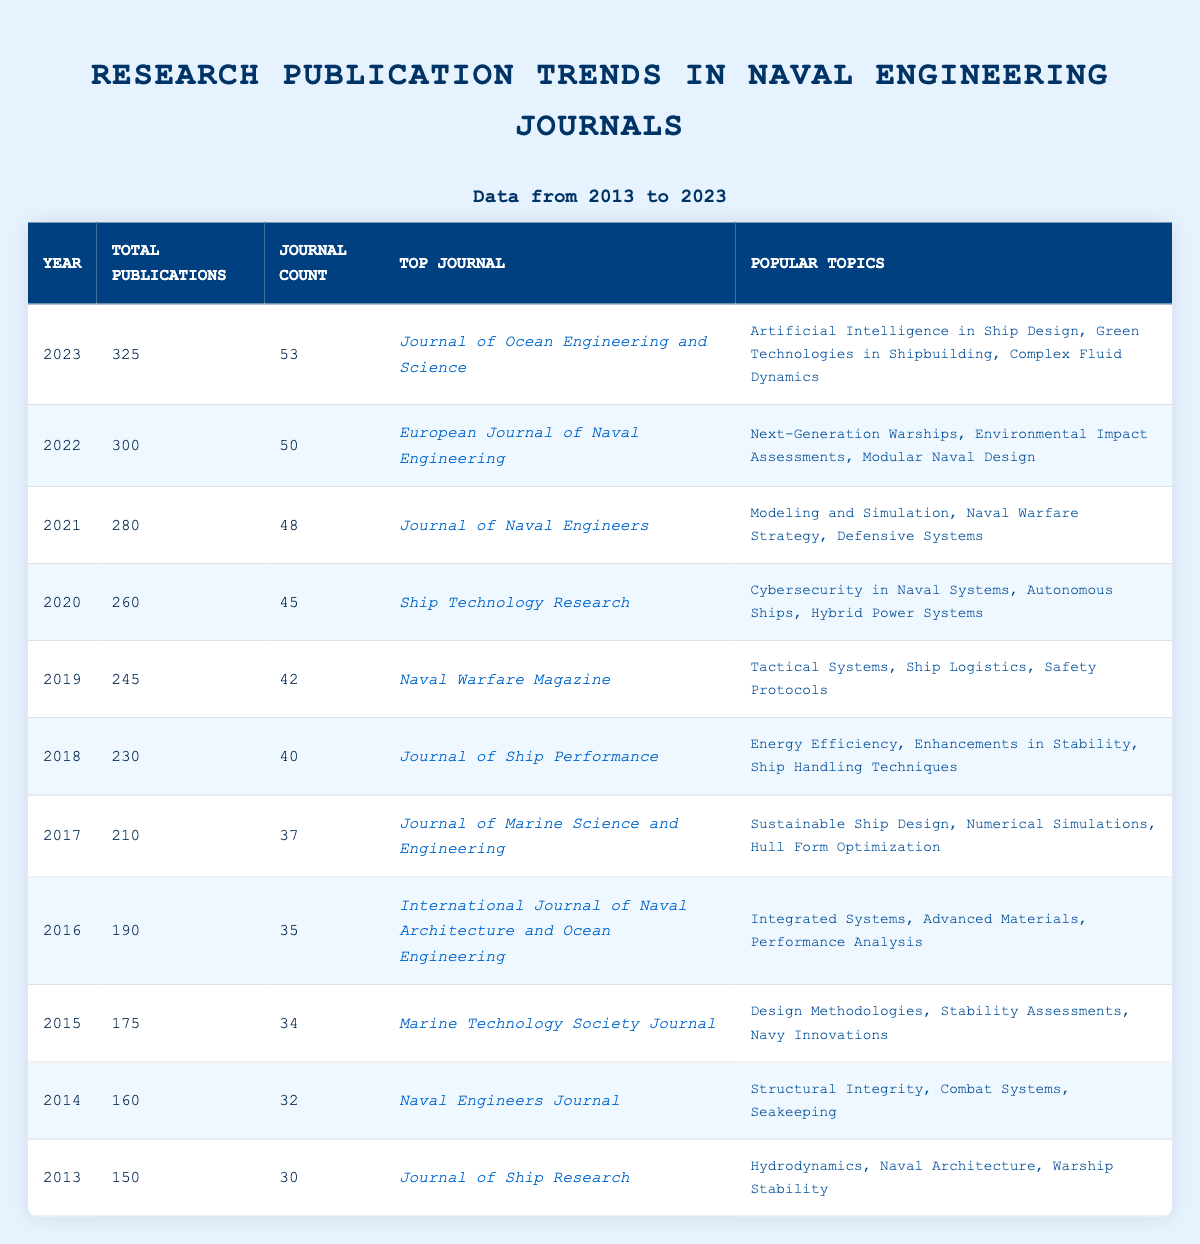What was the total number of publications in 2020? The table shows that the total number of publications for the year 2020 is listed directly in the respective row, which is 260.
Answer: 260 Which journal had the highest number of publications in 2022? The top journal in 2022, according to the table, is the European Journal of Naval Engineering.
Answer: European Journal of Naval Engineering What is the average number of publications per year over the last decade? To calculate the average, sum the total publications from 2013 to 2023: 150 + 160 + 175 + 190 + 210 + 230 + 245 + 260 + 280 + 300 + 325 = 2,325. Then divide by the number of years (11): 2325 / 11 = 211.36.
Answer: 211.36 Did the total number of publications increase every year from 2013 to 2023? Upon reviewing the table, it can be observed that the total publications increased from 2013 to 2023 without any decreases, confirming the trend of growth.
Answer: Yes Which year had the most publications and what was the count? The highest number of total publications is found in the year 2023, which has 325 publications listed in the table.
Answer: 2023, 325 What was the percentage increase in publications from 2019 to 2021? First calculate the difference in publications: 280 (2021) - 245 (2019) = 35. The percentage increase is then calculated as (35 / 245) * 100 = 14.29%.
Answer: 14.29% Which popular topic appeared most frequently as the highest count from 2013 to 2023? By examining the popular topics listed for each year, "Naval Engineering" is the overarching theme as most of the topics relate directly to this field throughout the decade, but each year features a distinct focus. So, a specific singular topic isn't repeated but linked by theme.
Answer: No singular topic How many new journals were introduced from 2013 to 2023? The journals and their counts for each year can be compared from 30 journals in 2013 to 53 journals in 2023. The addition of journals can be found by subtracting: 53 - 30 = 23 new journals.
Answer: 23 Which journal was consistently among the top journals from 2013 to 2023? The evaluation of the top journals indicates unique titles each year without repetition or consistency across the years. Hence, there is no journal that remained in the top position each year.
Answer: No In which year did the topic of "Cybersecurity in Naval Systems" rank as popular? This topic is stated as popular in the year 2020 as noted in the respective row of the table.
Answer: 2020 